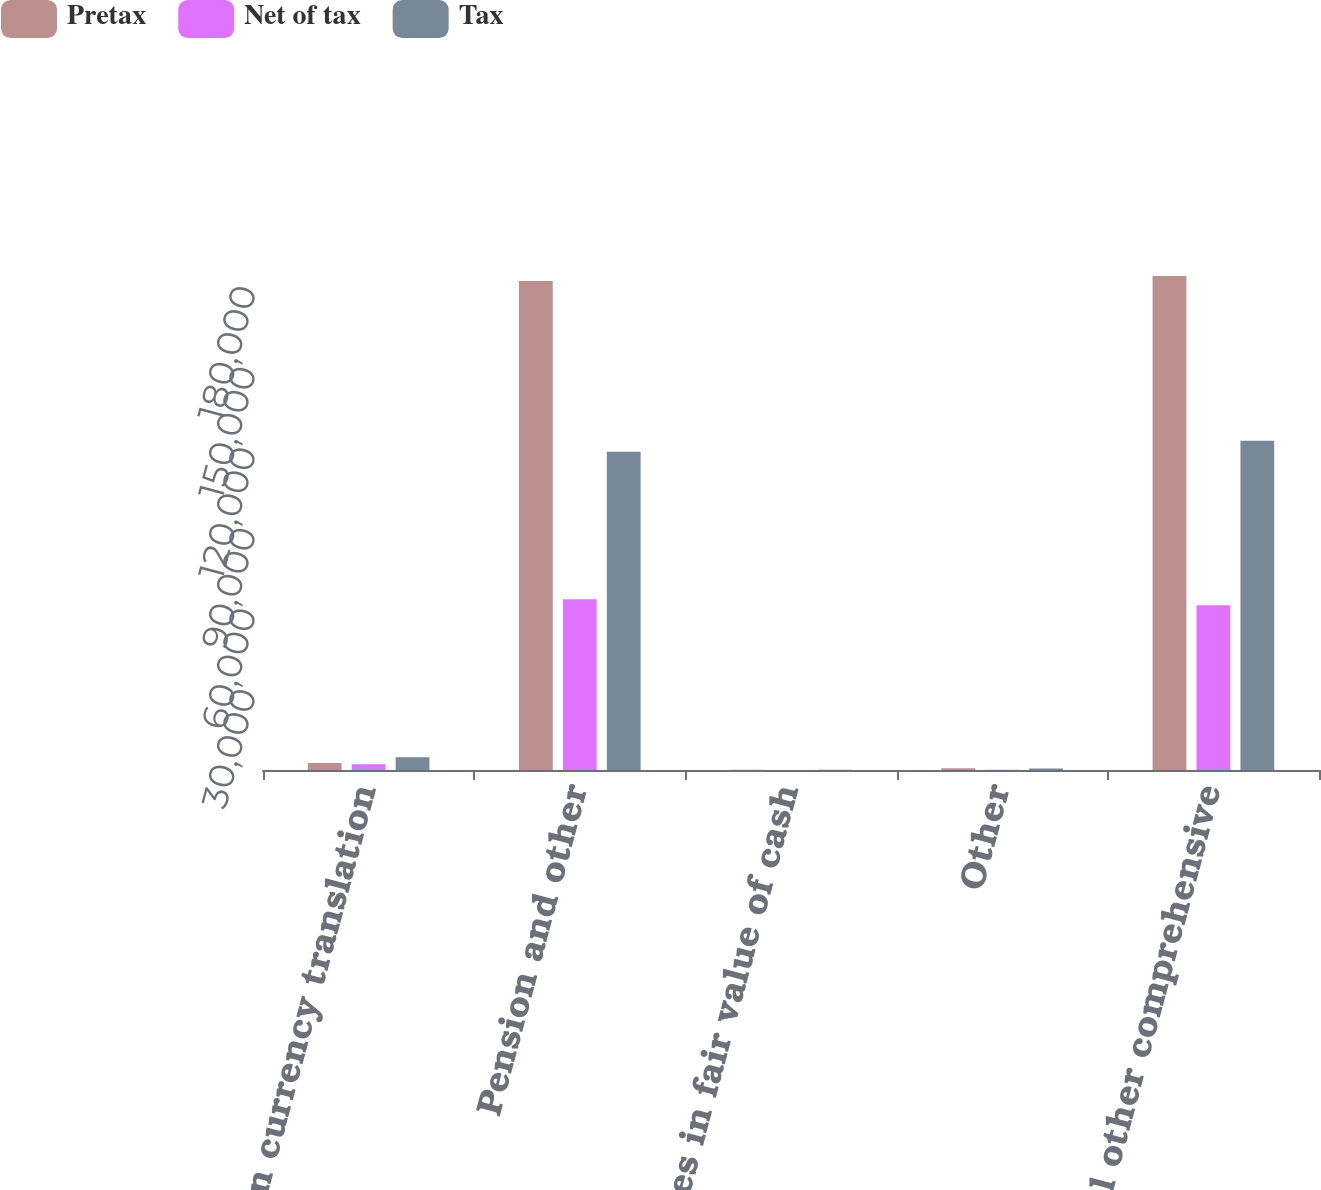<chart> <loc_0><loc_0><loc_500><loc_500><stacked_bar_chart><ecel><fcel>Foreign currency translation<fcel>Pension and other<fcel>Changes in fair value of cash<fcel>Other<fcel>Total other comprehensive<nl><fcel>Pretax<fcel>2602<fcel>182092<fcel>75<fcel>642<fcel>183977<nl><fcel>Net of tax<fcel>2134<fcel>63585<fcel>26<fcel>77<fcel>61348<nl><fcel>Tax<fcel>4736<fcel>118507<fcel>49<fcel>565<fcel>122629<nl></chart> 